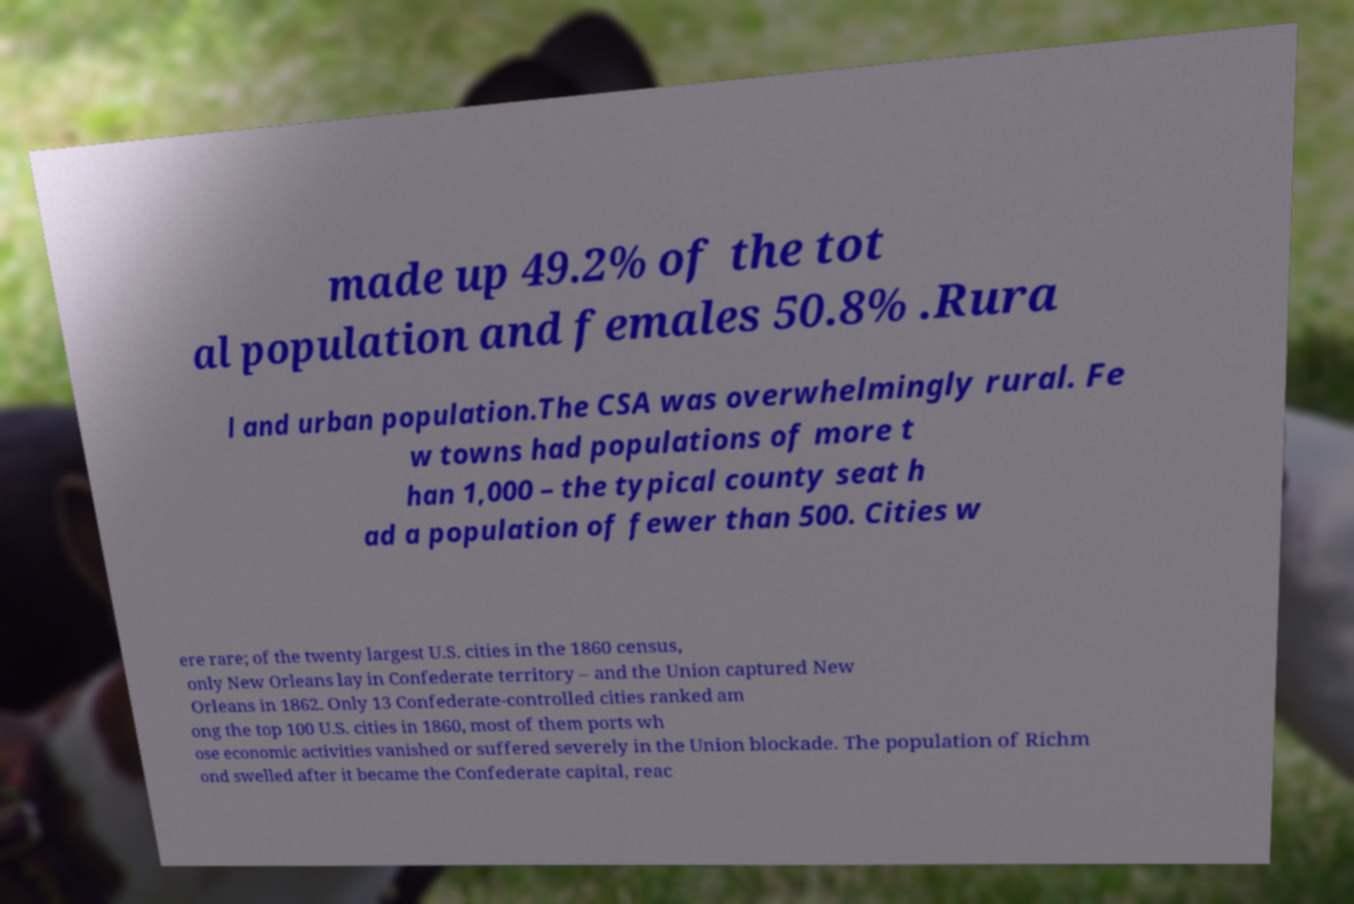Could you assist in decoding the text presented in this image and type it out clearly? made up 49.2% of the tot al population and females 50.8% .Rura l and urban population.The CSA was overwhelmingly rural. Fe w towns had populations of more t han 1,000 – the typical county seat h ad a population of fewer than 500. Cities w ere rare; of the twenty largest U.S. cities in the 1860 census, only New Orleans lay in Confederate territory – and the Union captured New Orleans in 1862. Only 13 Confederate-controlled cities ranked am ong the top 100 U.S. cities in 1860, most of them ports wh ose economic activities vanished or suffered severely in the Union blockade. The population of Richm ond swelled after it became the Confederate capital, reac 